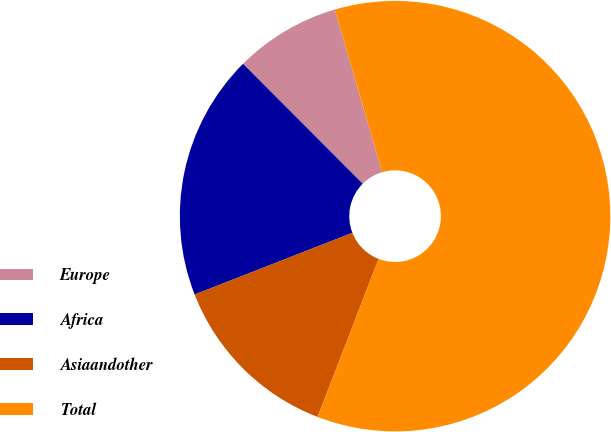Convert chart to OTSL. <chart><loc_0><loc_0><loc_500><loc_500><pie_chart><fcel>Europe<fcel>Africa<fcel>Asiaandother<fcel>Total<nl><fcel>7.96%<fcel>18.45%<fcel>13.21%<fcel>60.38%<nl></chart> 